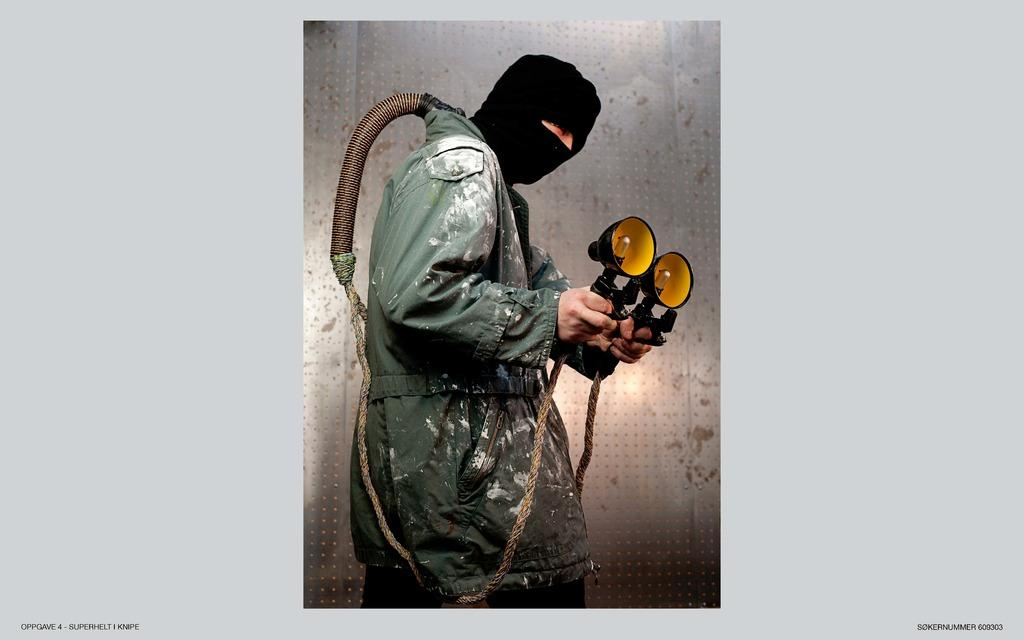What can be seen in the image? There is a person in the image. Can you describe the person's appearance? The person is wearing a black mask and jacket. What is the person holding in their hand? The person is holding lights in their hand. How are the lights attached to the person? The lights are attached to a rope around the person's neck. What can be seen in the background of the image? There is a metal wall in the background of the image. How many stockings are hanging on the metal wall in the image? There are no stockings visible in the image; only a person holding lights and a metal wall in the background. What type of pigs can be seen in the image? There are no pigs present in the image. 